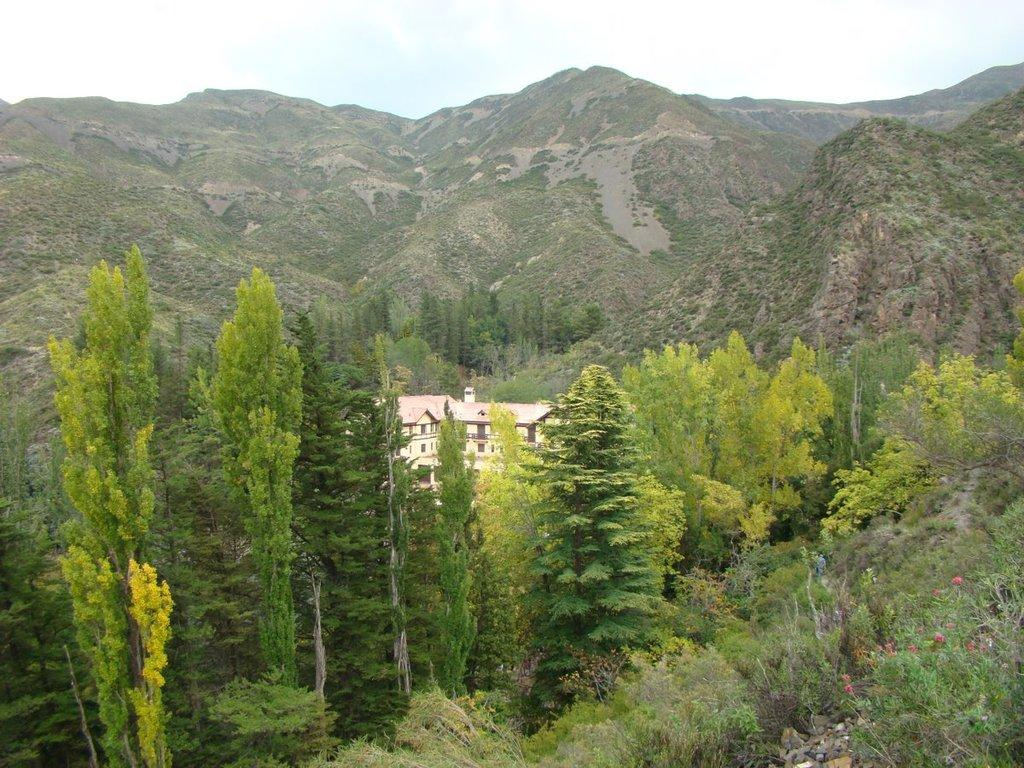What type of structure is visible in the image? There is a house in the image. What type of vegetation can be seen in the image? Trees are present in the image. What natural feature is visible in the background of the image? Mountains are visible in the image. What type of animal can be seen playing with a notebook in the image? There is no animal or notebook present in the image. 